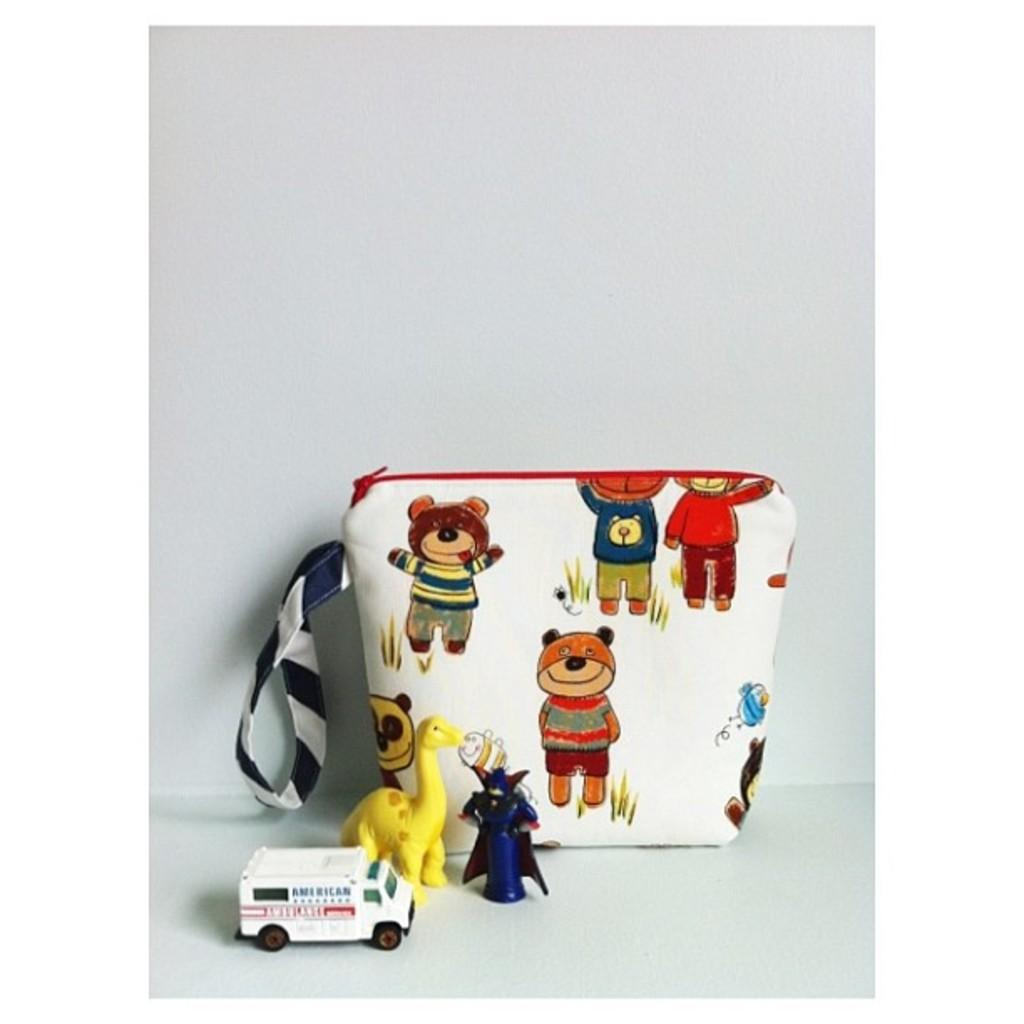What objects can be seen on the surface in the image? There are toys on the surface in the image. What is inside the bag that is visible in the image? There is a bag with images in the image. What color is the background of the image? The background of the image is white. Can you tell me how many rats are sitting on the toys in the image? There are no rats present in the image; it only features toys and a bag with images. Is there a crown visible on the surface in the image? There is no crown present in the image. 